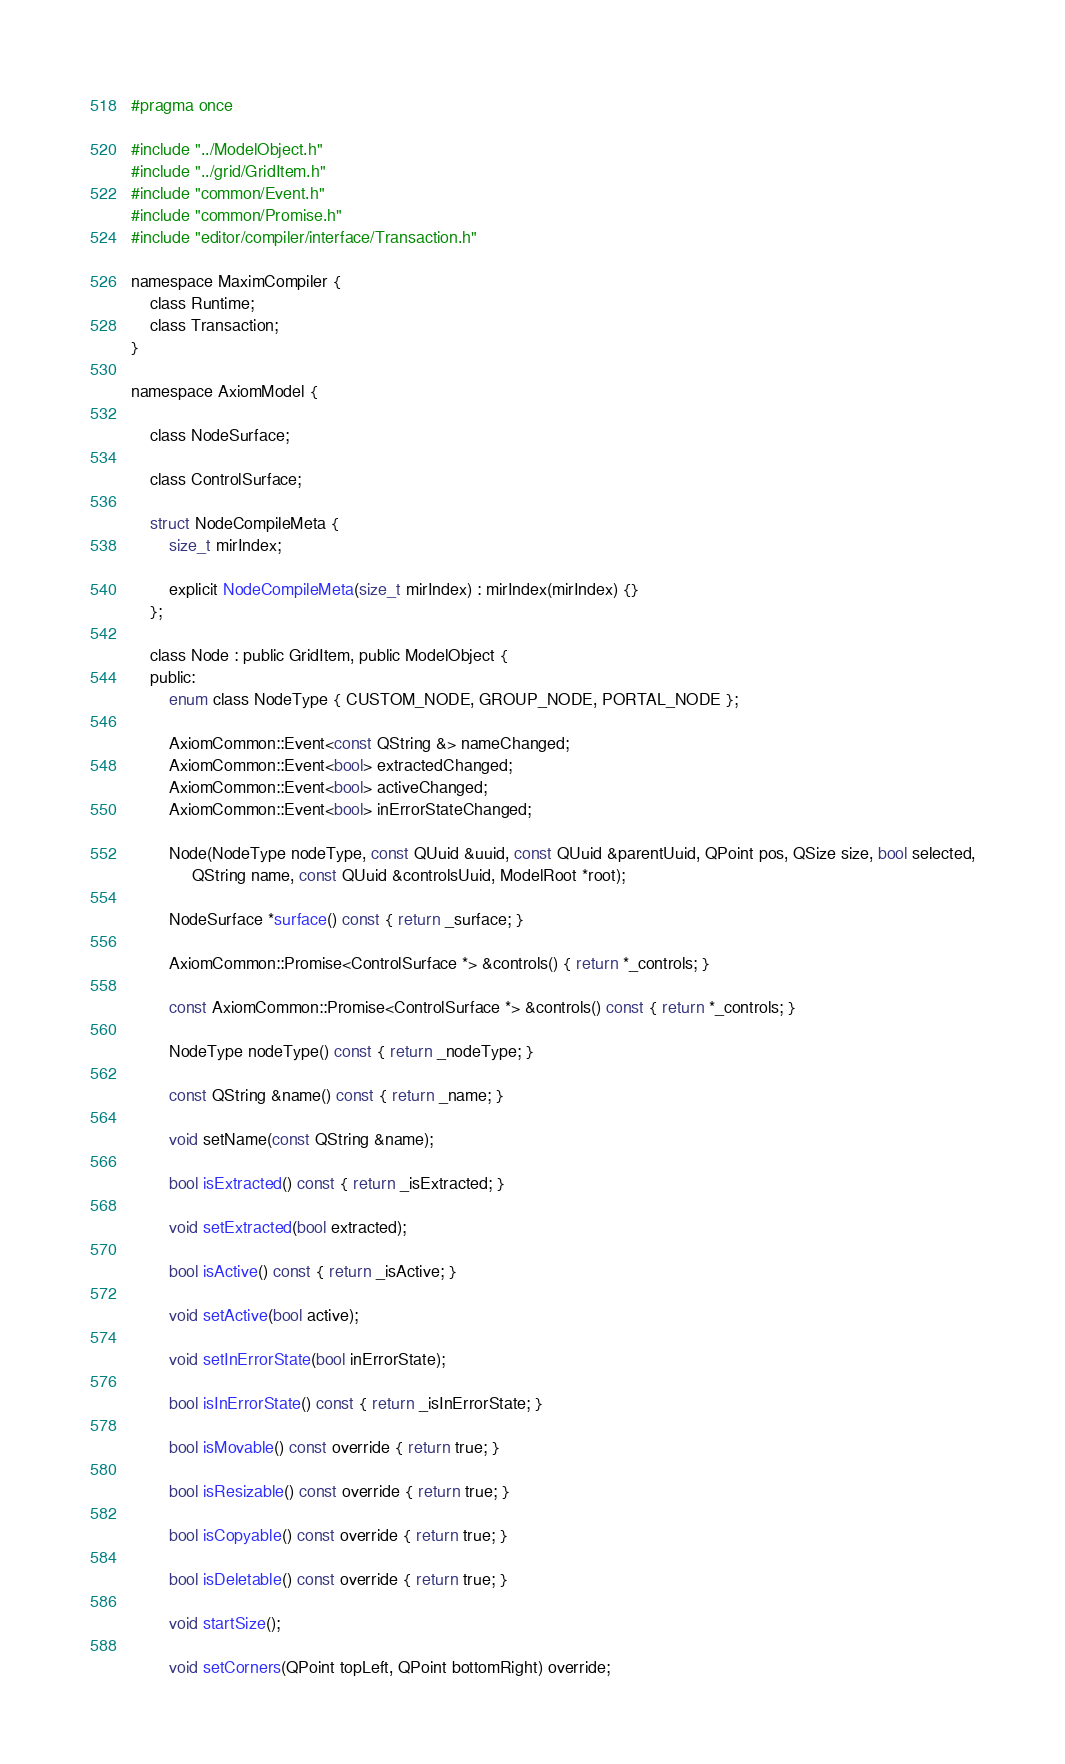Convert code to text. <code><loc_0><loc_0><loc_500><loc_500><_C_>#pragma once

#include "../ModelObject.h"
#include "../grid/GridItem.h"
#include "common/Event.h"
#include "common/Promise.h"
#include "editor/compiler/interface/Transaction.h"

namespace MaximCompiler {
    class Runtime;
    class Transaction;
}

namespace AxiomModel {

    class NodeSurface;

    class ControlSurface;

    struct NodeCompileMeta {
        size_t mirIndex;

        explicit NodeCompileMeta(size_t mirIndex) : mirIndex(mirIndex) {}
    };

    class Node : public GridItem, public ModelObject {
    public:
        enum class NodeType { CUSTOM_NODE, GROUP_NODE, PORTAL_NODE };

        AxiomCommon::Event<const QString &> nameChanged;
        AxiomCommon::Event<bool> extractedChanged;
        AxiomCommon::Event<bool> activeChanged;
        AxiomCommon::Event<bool> inErrorStateChanged;

        Node(NodeType nodeType, const QUuid &uuid, const QUuid &parentUuid, QPoint pos, QSize size, bool selected,
             QString name, const QUuid &controlsUuid, ModelRoot *root);

        NodeSurface *surface() const { return _surface; }

        AxiomCommon::Promise<ControlSurface *> &controls() { return *_controls; }

        const AxiomCommon::Promise<ControlSurface *> &controls() const { return *_controls; }

        NodeType nodeType() const { return _nodeType; }

        const QString &name() const { return _name; }

        void setName(const QString &name);

        bool isExtracted() const { return _isExtracted; }

        void setExtracted(bool extracted);

        bool isActive() const { return _isActive; }

        void setActive(bool active);

        void setInErrorState(bool inErrorState);

        bool isInErrorState() const { return _isInErrorState; }

        bool isMovable() const override { return true; }

        bool isResizable() const override { return true; }

        bool isCopyable() const override { return true; }

        bool isDeletable() const override { return true; }

        void startSize();

        void setCorners(QPoint topLeft, QPoint bottomRight) override;
</code> 